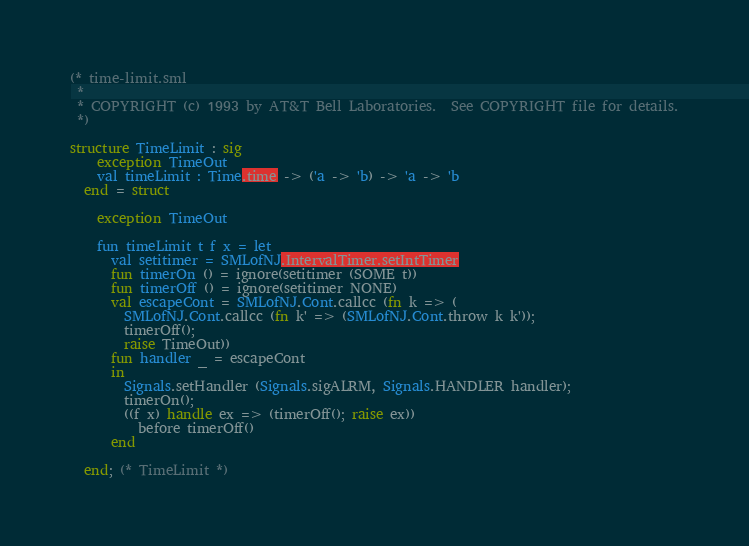<code> <loc_0><loc_0><loc_500><loc_500><_SML_>(* time-limit.sml
 *
 * COPYRIGHT (c) 1993 by AT&T Bell Laboratories.  See COPYRIGHT file for details.
 *)

structure TimeLimit : sig
    exception TimeOut
    val timeLimit : Time.time -> ('a -> 'b) -> 'a -> 'b
  end = struct

    exception TimeOut

    fun timeLimit t f x = let
	  val setitimer = SMLofNJ.IntervalTimer.setIntTimer
	  fun timerOn () = ignore(setitimer (SOME t))
	  fun timerOff () = ignore(setitimer NONE)
	  val escapeCont = SMLofNJ.Cont.callcc (fn k => (
		SMLofNJ.Cont.callcc (fn k' => (SMLofNJ.Cont.throw k k'));
		timerOff();
		raise TimeOut))
	  fun handler _ = escapeCont
	  in
	    Signals.setHandler (Signals.sigALRM, Signals.HANDLER handler);
	    timerOn();
	    ((f x) handle ex => (timerOff(); raise ex))
	      before timerOff()
	  end

  end; (* TimeLimit *)
</code> 